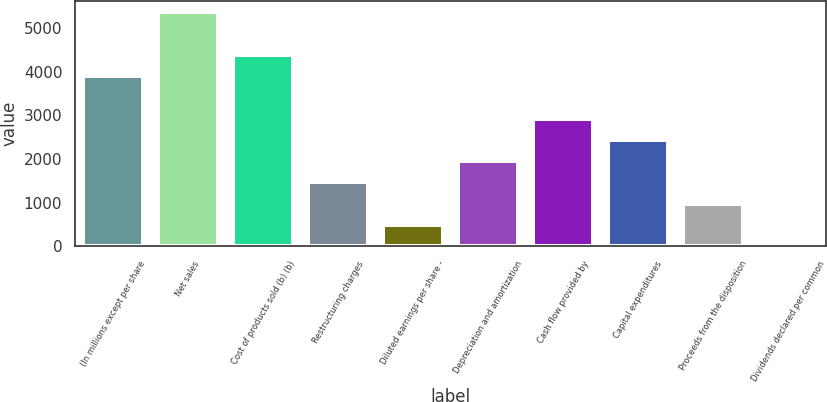Convert chart. <chart><loc_0><loc_0><loc_500><loc_500><bar_chart><fcel>(In millions except per share<fcel>Net sales<fcel>Cost of products sold (b) (b)<fcel>Restructuring charges<fcel>Diluted earnings per share -<fcel>Depreciation and amortization<fcel>Cash flow provided by<fcel>Capital expenditures<fcel>Proceeds from the disposition<fcel>Dividends declared per common<nl><fcel>3900.66<fcel>5363.19<fcel>4388.17<fcel>1463.11<fcel>488.09<fcel>1950.62<fcel>2925.64<fcel>2438.13<fcel>975.6<fcel>0.58<nl></chart> 